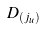Convert formula to latex. <formula><loc_0><loc_0><loc_500><loc_500>D _ { ( j _ { u } ) }</formula> 